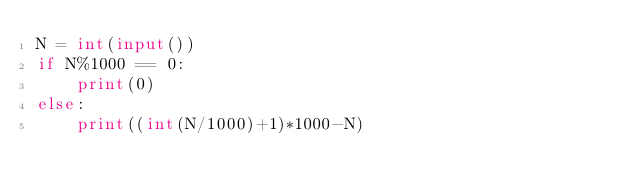Convert code to text. <code><loc_0><loc_0><loc_500><loc_500><_Python_>N = int(input())
if N%1000 == 0:
    print(0)
else:
    print((int(N/1000)+1)*1000-N)
</code> 